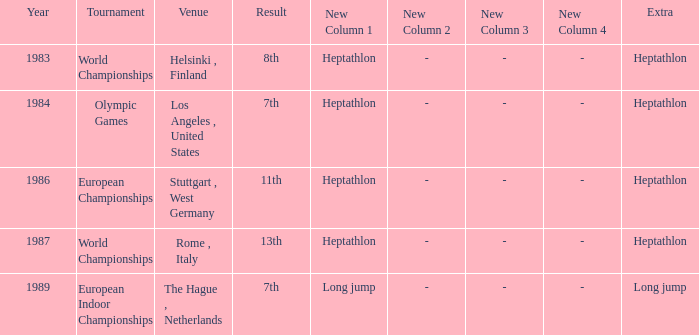How often are the Olympic games hosted? 1984.0. 